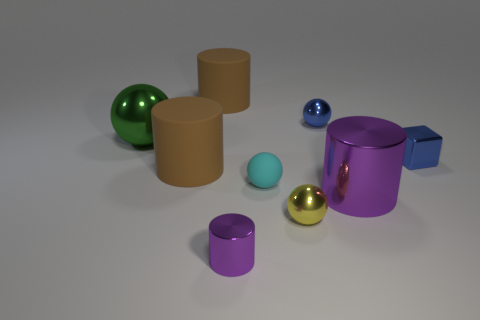Subtract all purple cylinders. How many cylinders are left? 2 Subtract all yellow shiny spheres. How many spheres are left? 3 Subtract 0 gray cylinders. How many objects are left? 9 Subtract all blocks. How many objects are left? 8 Subtract 2 spheres. How many spheres are left? 2 Subtract all cyan cylinders. Subtract all purple balls. How many cylinders are left? 4 Subtract all blue cylinders. How many green balls are left? 1 Subtract all large things. Subtract all small objects. How many objects are left? 0 Add 7 purple objects. How many purple objects are left? 9 Add 6 purple metal cylinders. How many purple metal cylinders exist? 8 